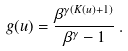Convert formula to latex. <formula><loc_0><loc_0><loc_500><loc_500>g ( u ) = \frac { \beta ^ { \gamma ( K ( u ) + 1 ) } } { \beta ^ { \gamma } - 1 } \, .</formula> 